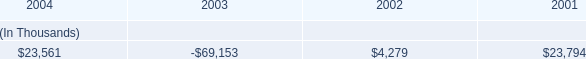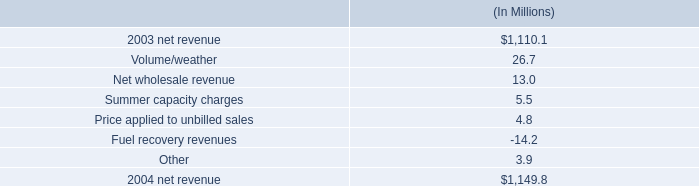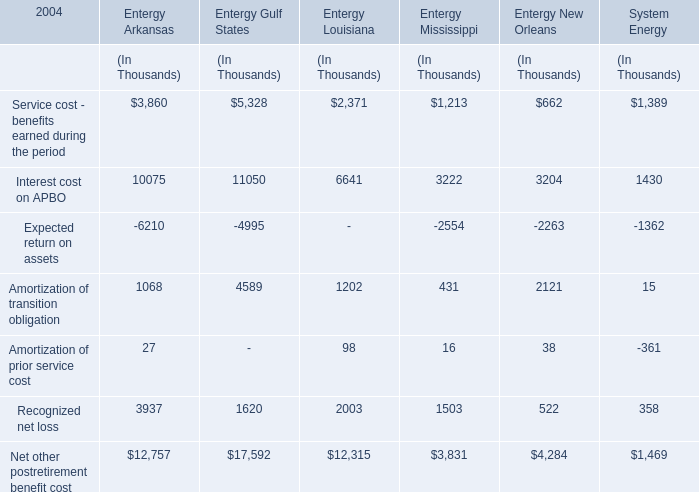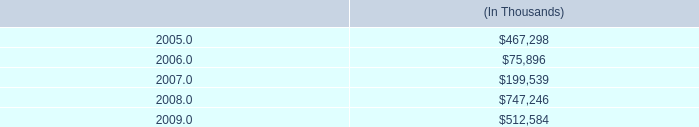what portion of the net change in net revenue during 2004 is due to the change in volume/weather for entergy gulf states , inc? 
Computations: (26.7 / (1149.8 - 1110.1))
Answer: 0.67254. 